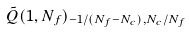<formula> <loc_0><loc_0><loc_500><loc_500>\tilde { Q } ( 1 , N _ { f } ) _ { - 1 / ( N _ { f } - N _ { c } ) , N _ { c } / N _ { f } }</formula> 